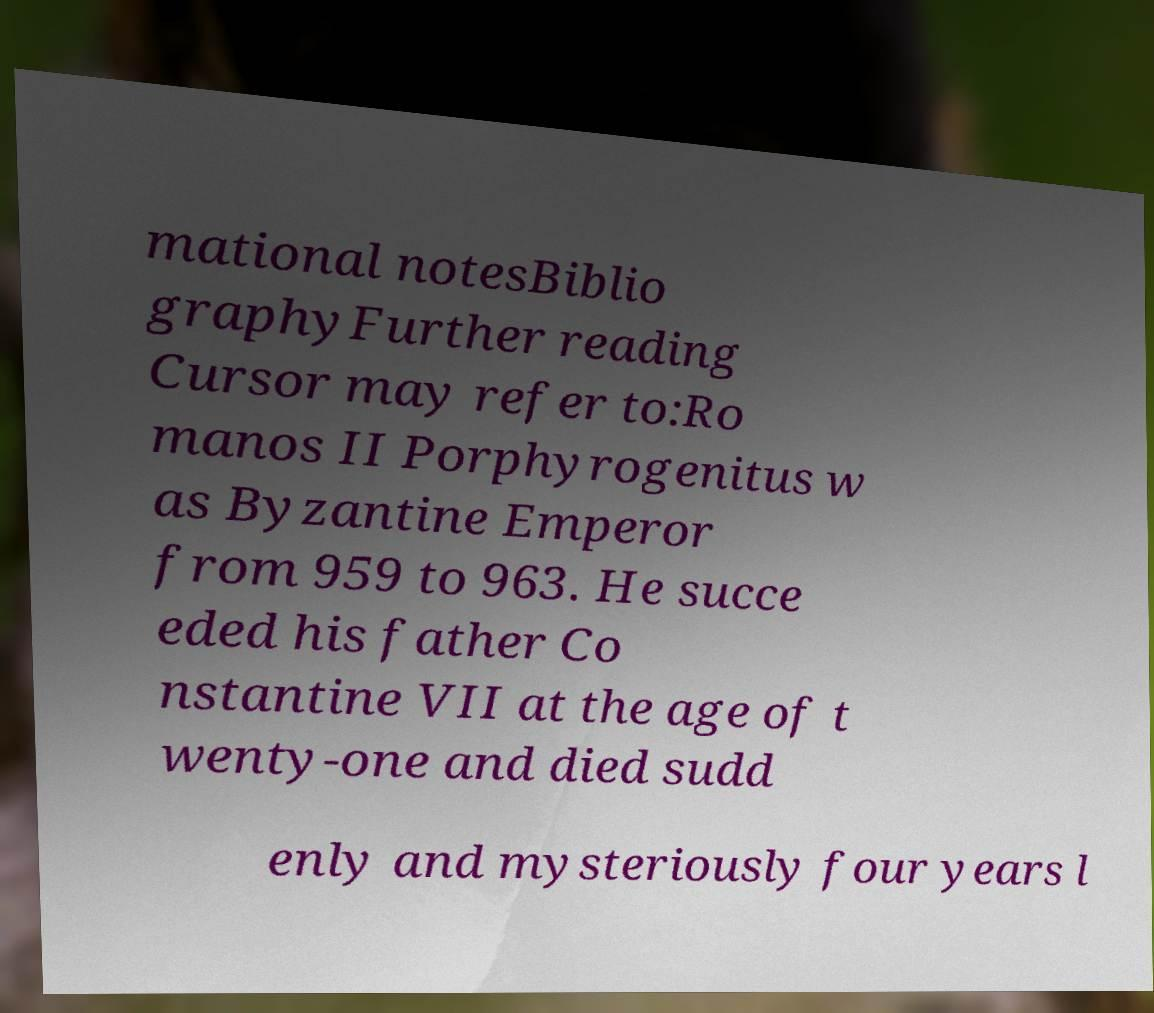Could you assist in decoding the text presented in this image and type it out clearly? mational notesBiblio graphyFurther reading Cursor may refer to:Ro manos II Porphyrogenitus w as Byzantine Emperor from 959 to 963. He succe eded his father Co nstantine VII at the age of t wenty-one and died sudd enly and mysteriously four years l 